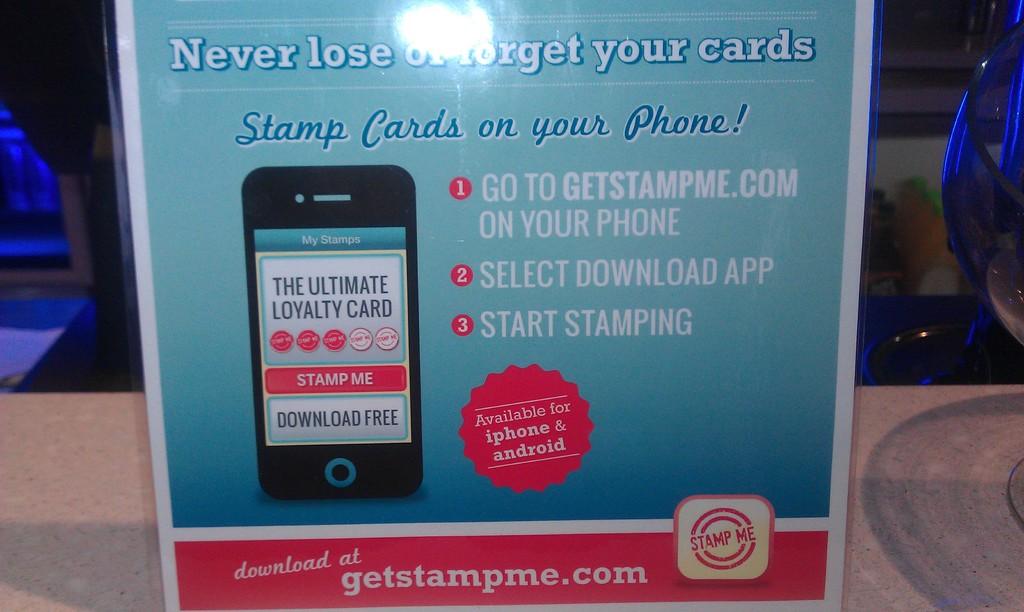What kind of cards can you put on your phone?
Give a very brief answer. Stamp cards. What is the webpage address?
Your response must be concise. Getstampme.com. 